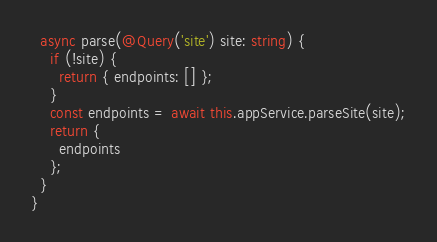Convert code to text. <code><loc_0><loc_0><loc_500><loc_500><_TypeScript_>  async parse(@Query('site') site: string) {
    if (!site) {
      return { endpoints: [] };
    }
    const endpoints = await this.appService.parseSite(site);
    return {
      endpoints
    };
  }
}
</code> 